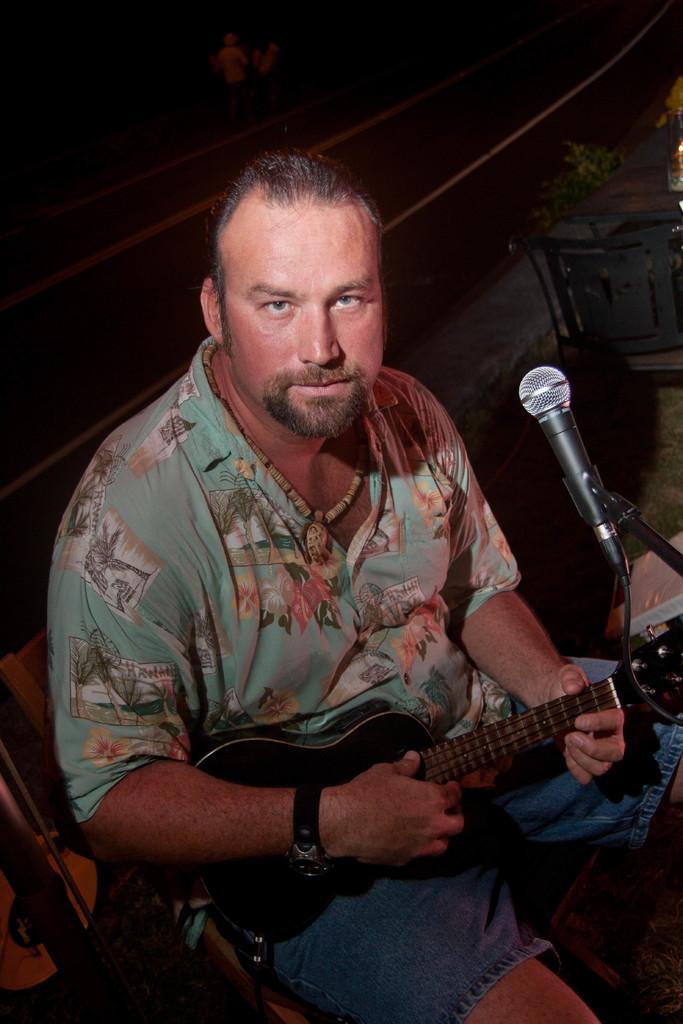In one or two sentences, can you explain what this image depicts? Background is dark. Here we can see a table and a chair. We can see one man sitting on a chair in front of a mike and playing guitar. 